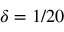<formula> <loc_0><loc_0><loc_500><loc_500>\delta = 1 / 2 0</formula> 